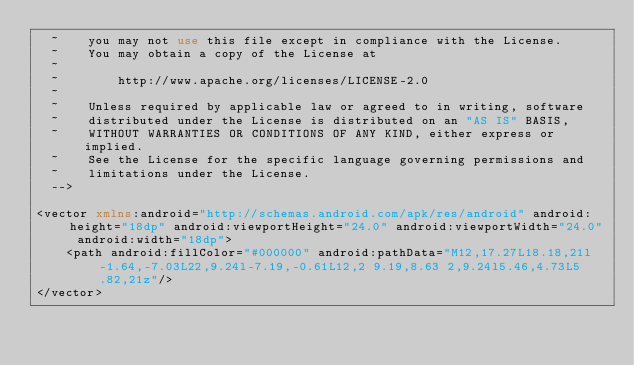Convert code to text. <code><loc_0><loc_0><loc_500><loc_500><_XML_>  ~    you may not use this file except in compliance with the License.
  ~    You may obtain a copy of the License at
  ~
  ~        http://www.apache.org/licenses/LICENSE-2.0
  ~
  ~    Unless required by applicable law or agreed to in writing, software
  ~    distributed under the License is distributed on an "AS IS" BASIS,
  ~    WITHOUT WARRANTIES OR CONDITIONS OF ANY KIND, either express or implied.
  ~    See the License for the specific language governing permissions and
  ~    limitations under the License.
  -->

<vector xmlns:android="http://schemas.android.com/apk/res/android" android:height="18dp" android:viewportHeight="24.0" android:viewportWidth="24.0" android:width="18dp">
    <path android:fillColor="#000000" android:pathData="M12,17.27L18.18,21l-1.64,-7.03L22,9.24l-7.19,-0.61L12,2 9.19,8.63 2,9.24l5.46,4.73L5.82,21z"/>
</vector>
</code> 